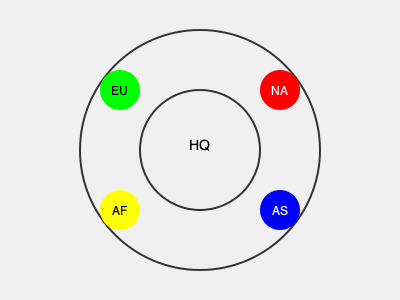Analyze the spatial distribution of a multinational corporation's global offices. If the company aims to minimize the average distance between regional offices and the headquarters (HQ) while maintaining global coverage, which region should be prioritized for expansion or relocation to achieve better balance? To answer this question, we need to analyze the spatial distribution of the offices and their relation to the headquarters:

1. Identify the regions: NA (North America), EU (Europe), AS (Asia), and AF (Africa).

2. Observe the current distribution:
   - NA and AS are positioned opposite each other on the outer circle.
   - EU and AF are positioned opposite each other on the outer circle.
   - The four regions form a roughly square shape around the HQ.

3. Consider the balance:
   - NA and EU are closer to each other, representing the "Global North."
   - AS and AF are more distant from each other and from the "Global North" offices.

4. Analyze the gaps:
   - The largest unoccupied area is between AS and AF.
   - This gap represents the Middle East and Oceania regions.

5. Consider socio-economic factors:
   - The Middle East and Oceania are significant in terms of global trade and emerging markets.
   - These regions could bridge the gap between Asia, Africa, and Europe.

6. Evaluate the impact:
   - Adding an office in the Middle East or Oceania would:
     a) Reduce the average distance between regional offices and HQ.
     b) Improve global coverage by filling the largest spatial gap.
     c) Potentially balance the "Global North" and "Global South" representation.

Therefore, to achieve better balance and minimize average distances, the company should prioritize expansion or relocation to the Middle East or Oceania region.
Answer: Middle East or Oceania 